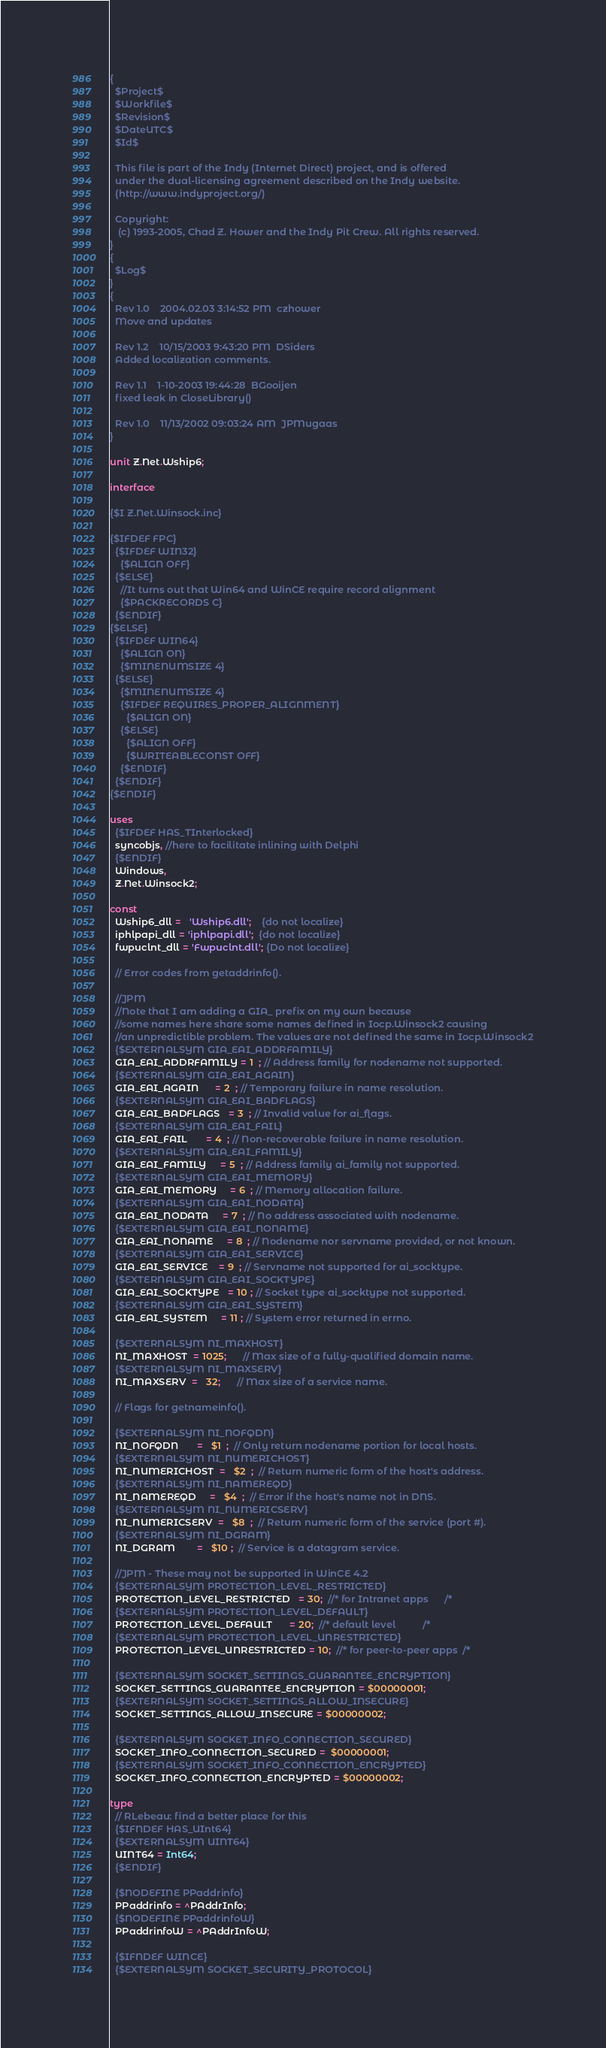Convert code to text. <code><loc_0><loc_0><loc_500><loc_500><_Pascal_>{
  $Project$
  $Workfile$
  $Revision$
  $DateUTC$
  $Id$

  This file is part of the Indy (Internet Direct) project, and is offered
  under the dual-licensing agreement described on the Indy website.
  (http://www.indyproject.org/)

  Copyright:
   (c) 1993-2005, Chad Z. Hower and the Indy Pit Crew. All rights reserved.
}
{
  $Log$
}
{
  Rev 1.0    2004.02.03 3:14:52 PM  czhower
  Move and updates

  Rev 1.2    10/15/2003 9:43:20 PM  DSiders
  Added localization comments.

  Rev 1.1    1-10-2003 19:44:28  BGooijen
  fixed leak in CloseLibrary()

  Rev 1.0    11/13/2002 09:03:24 AM  JPMugaas
}

unit Z.Net.Wship6;

interface

{$I Z.Net.Winsock.inc}

{$IFDEF FPC}
  {$IFDEF WIN32}
    {$ALIGN OFF}
  {$ELSE}
    //It turns out that Win64 and WinCE require record alignment
    {$PACKRECORDS C}
  {$ENDIF}
{$ELSE}
  {$IFDEF WIN64}
    {$ALIGN ON}
    {$MINENUMSIZE 4}
  {$ELSE}
    {$MINENUMSIZE 4}
    {$IFDEF REQUIRES_PROPER_ALIGNMENT}
      {$ALIGN ON}
    {$ELSE}
      {$ALIGN OFF}
      {$WRITEABLECONST OFF}
    {$ENDIF}
  {$ENDIF}
{$ENDIF}

uses
  {$IFDEF HAS_TInterlocked}
  syncobjs, //here to facilitate inlining with Delphi
  {$ENDIF}
  Windows,
  Z.Net.Winsock2;

const
  Wship6_dll =   'Wship6.dll';    {do not localize}
  iphlpapi_dll = 'iphlpapi.dll';  {do not localize}
  fwpuclnt_dll = 'Fwpuclnt.dll'; {Do not localize}

  // Error codes from getaddrinfo().

  //JPM
  //Note that I am adding a GIA_ prefix on my own because
  //some names here share some names defined in Iocp.Winsock2 causing
  //an unpredictible problem. The values are not defined the same in Iocp.Winsock2
  {$EXTERNALSYM GIA_EAI_ADDRFAMILY}
  GIA_EAI_ADDRFAMILY = 1  ; // Address family for nodename not supported.
  {$EXTERNALSYM GIA_EAI_AGAIN}
  GIA_EAI_AGAIN      = 2  ; // Temporary failure in name resolution.
  {$EXTERNALSYM GIA_EAI_BADFLAGS}
  GIA_EAI_BADFLAGS   = 3  ; // Invalid value for ai_flags.
  {$EXTERNALSYM GIA_EAI_FAIL}
  GIA_EAI_FAIL       = 4  ; // Non-recoverable failure in name resolution.
  {$EXTERNALSYM GIA_EAI_FAMILY}
  GIA_EAI_FAMILY     = 5  ; // Address family ai_family not supported.
  {$EXTERNALSYM GIA_EAI_MEMORY}
  GIA_EAI_MEMORY     = 6  ; // Memory allocation failure.
  {$EXTERNALSYM GIA_EAI_NODATA}
  GIA_EAI_NODATA     = 7  ; // No address associated with nodename.
  {$EXTERNALSYM GIA_EAI_NONAME}
  GIA_EAI_NONAME     = 8  ; // Nodename nor servname provided, or not known.
  {$EXTERNALSYM GIA_EAI_SERVICE}
  GIA_EAI_SERVICE    = 9  ; // Servname not supported for ai_socktype.
  {$EXTERNALSYM GIA_EAI_SOCKTYPE}
  GIA_EAI_SOCKTYPE   = 10 ; // Socket type ai_socktype not supported.
  {$EXTERNALSYM GIA_EAI_SYSTEM}
  GIA_EAI_SYSTEM     = 11 ; // System error returned in errno.

  {$EXTERNALSYM NI_MAXHOST}
  NI_MAXHOST  = 1025;      // Max size of a fully-qualified domain name.
  {$EXTERNALSYM NI_MAXSERV}
  NI_MAXSERV  =   32;      // Max size of a service name.

  // Flags for getnameinfo().

  {$EXTERNALSYM NI_NOFQDN}
  NI_NOFQDN       =   $1  ;  // Only return nodename portion for local hosts.
  {$EXTERNALSYM NI_NUMERICHOST}
  NI_NUMERICHOST  =   $2  ;  // Return numeric form of the host's address.
  {$EXTERNALSYM NI_NAMEREQD}
  NI_NAMEREQD     =   $4  ;  // Error if the host's name not in DNS.
  {$EXTERNALSYM NI_NUMERICSERV}
  NI_NUMERICSERV  =   $8  ;  // Return numeric form of the service (port #).
  {$EXTERNALSYM NI_DGRAM}
  NI_DGRAM        =   $10 ;  // Service is a datagram service.

  //JPM - These may not be supported in WinCE 4.2
  {$EXTERNALSYM PROTECTION_LEVEL_RESTRICTED}
  PROTECTION_LEVEL_RESTRICTED   = 30;  //* for Intranet apps      /*
  {$EXTERNALSYM PROTECTION_LEVEL_DEFAULT}
  PROTECTION_LEVEL_DEFAULT      = 20;  //* default level          /*
  {$EXTERNALSYM PROTECTION_LEVEL_UNRESTRICTED}
  PROTECTION_LEVEL_UNRESTRICTED = 10;  //* for peer-to-peer apps  /*

  {$EXTERNALSYM SOCKET_SETTINGS_GUARANTEE_ENCRYPTION}
  SOCKET_SETTINGS_GUARANTEE_ENCRYPTION = $00000001;
  {$EXTERNALSYM SOCKET_SETTINGS_ALLOW_INSECURE}
  SOCKET_SETTINGS_ALLOW_INSECURE = $00000002;
  
  {$EXTERNALSYM SOCKET_INFO_CONNECTION_SECURED}
  SOCKET_INFO_CONNECTION_SECURED =  $00000001;
  {$EXTERNALSYM SOCKET_INFO_CONNECTION_ENCRYPTED}
  SOCKET_INFO_CONNECTION_ENCRYPTED = $00000002;

type
  // RLebeau: find a better place for this
  {$IFNDEF HAS_UInt64}
  {$EXTERNALSYM UINT64}
  UINT64 = Int64;
  {$ENDIF}

  {$NODEFINE PPaddrinfo}
  PPaddrinfo = ^PAddrInfo;
  {$NODEFINE PPaddrinfoW}
  PPaddrinfoW = ^PAddrInfoW;

  {$IFNDEF WINCE}
  {$EXTERNALSYM SOCKET_SECURITY_PROTOCOL}</code> 